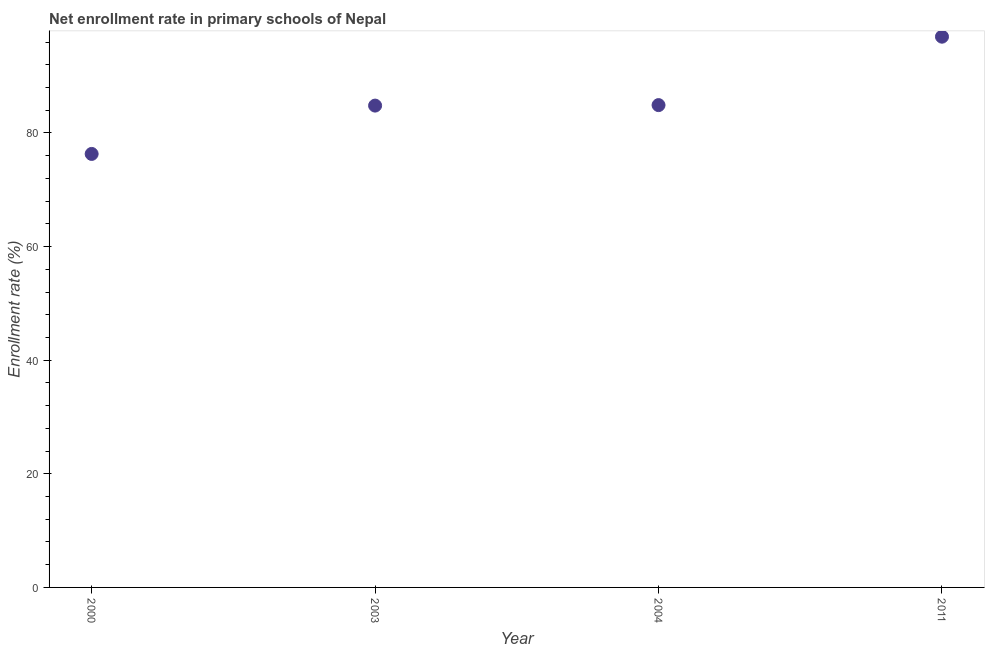What is the net enrollment rate in primary schools in 2004?
Ensure brevity in your answer.  84.91. Across all years, what is the maximum net enrollment rate in primary schools?
Your answer should be very brief. 96.95. Across all years, what is the minimum net enrollment rate in primary schools?
Offer a terse response. 76.31. In which year was the net enrollment rate in primary schools minimum?
Make the answer very short. 2000. What is the sum of the net enrollment rate in primary schools?
Your response must be concise. 342.99. What is the difference between the net enrollment rate in primary schools in 2000 and 2011?
Offer a terse response. -20.64. What is the average net enrollment rate in primary schools per year?
Offer a very short reply. 85.75. What is the median net enrollment rate in primary schools?
Your answer should be very brief. 84.86. In how many years, is the net enrollment rate in primary schools greater than 84 %?
Provide a succinct answer. 3. Do a majority of the years between 2003 and 2000 (inclusive) have net enrollment rate in primary schools greater than 28 %?
Your response must be concise. No. What is the ratio of the net enrollment rate in primary schools in 2003 to that in 2011?
Ensure brevity in your answer.  0.87. Is the difference between the net enrollment rate in primary schools in 2000 and 2004 greater than the difference between any two years?
Offer a terse response. No. What is the difference between the highest and the second highest net enrollment rate in primary schools?
Ensure brevity in your answer.  12.04. Is the sum of the net enrollment rate in primary schools in 2003 and 2011 greater than the maximum net enrollment rate in primary schools across all years?
Your answer should be very brief. Yes. What is the difference between the highest and the lowest net enrollment rate in primary schools?
Your answer should be compact. 20.64. In how many years, is the net enrollment rate in primary schools greater than the average net enrollment rate in primary schools taken over all years?
Your answer should be very brief. 1. Does the net enrollment rate in primary schools monotonically increase over the years?
Offer a very short reply. Yes. How many dotlines are there?
Keep it short and to the point. 1. Does the graph contain any zero values?
Make the answer very short. No. What is the title of the graph?
Keep it short and to the point. Net enrollment rate in primary schools of Nepal. What is the label or title of the Y-axis?
Offer a very short reply. Enrollment rate (%). What is the Enrollment rate (%) in 2000?
Give a very brief answer. 76.31. What is the Enrollment rate (%) in 2003?
Offer a terse response. 84.82. What is the Enrollment rate (%) in 2004?
Provide a succinct answer. 84.91. What is the Enrollment rate (%) in 2011?
Ensure brevity in your answer.  96.95. What is the difference between the Enrollment rate (%) in 2000 and 2003?
Your answer should be compact. -8.51. What is the difference between the Enrollment rate (%) in 2000 and 2004?
Your response must be concise. -8.6. What is the difference between the Enrollment rate (%) in 2000 and 2011?
Offer a very short reply. -20.64. What is the difference between the Enrollment rate (%) in 2003 and 2004?
Your answer should be compact. -0.09. What is the difference between the Enrollment rate (%) in 2003 and 2011?
Keep it short and to the point. -12.13. What is the difference between the Enrollment rate (%) in 2004 and 2011?
Offer a very short reply. -12.04. What is the ratio of the Enrollment rate (%) in 2000 to that in 2004?
Make the answer very short. 0.9. What is the ratio of the Enrollment rate (%) in 2000 to that in 2011?
Offer a terse response. 0.79. What is the ratio of the Enrollment rate (%) in 2004 to that in 2011?
Your answer should be very brief. 0.88. 